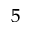<formula> <loc_0><loc_0><loc_500><loc_500>^ { 5 }</formula> 